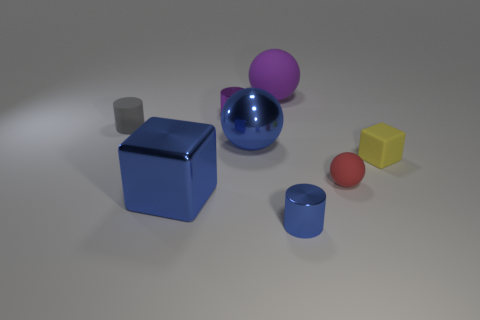Subtract all purple shiny cylinders. How many cylinders are left? 2 Add 1 balls. How many objects exist? 9 Subtract all cubes. How many objects are left? 6 Subtract 0 brown cylinders. How many objects are left? 8 Subtract all yellow cylinders. Subtract all red cubes. How many cylinders are left? 3 Subtract all tiny purple matte spheres. Subtract all tiny yellow blocks. How many objects are left? 7 Add 5 purple rubber balls. How many purple rubber balls are left? 6 Add 5 brown things. How many brown things exist? 5 